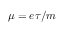<formula> <loc_0><loc_0><loc_500><loc_500>\mu = e \tau / m</formula> 